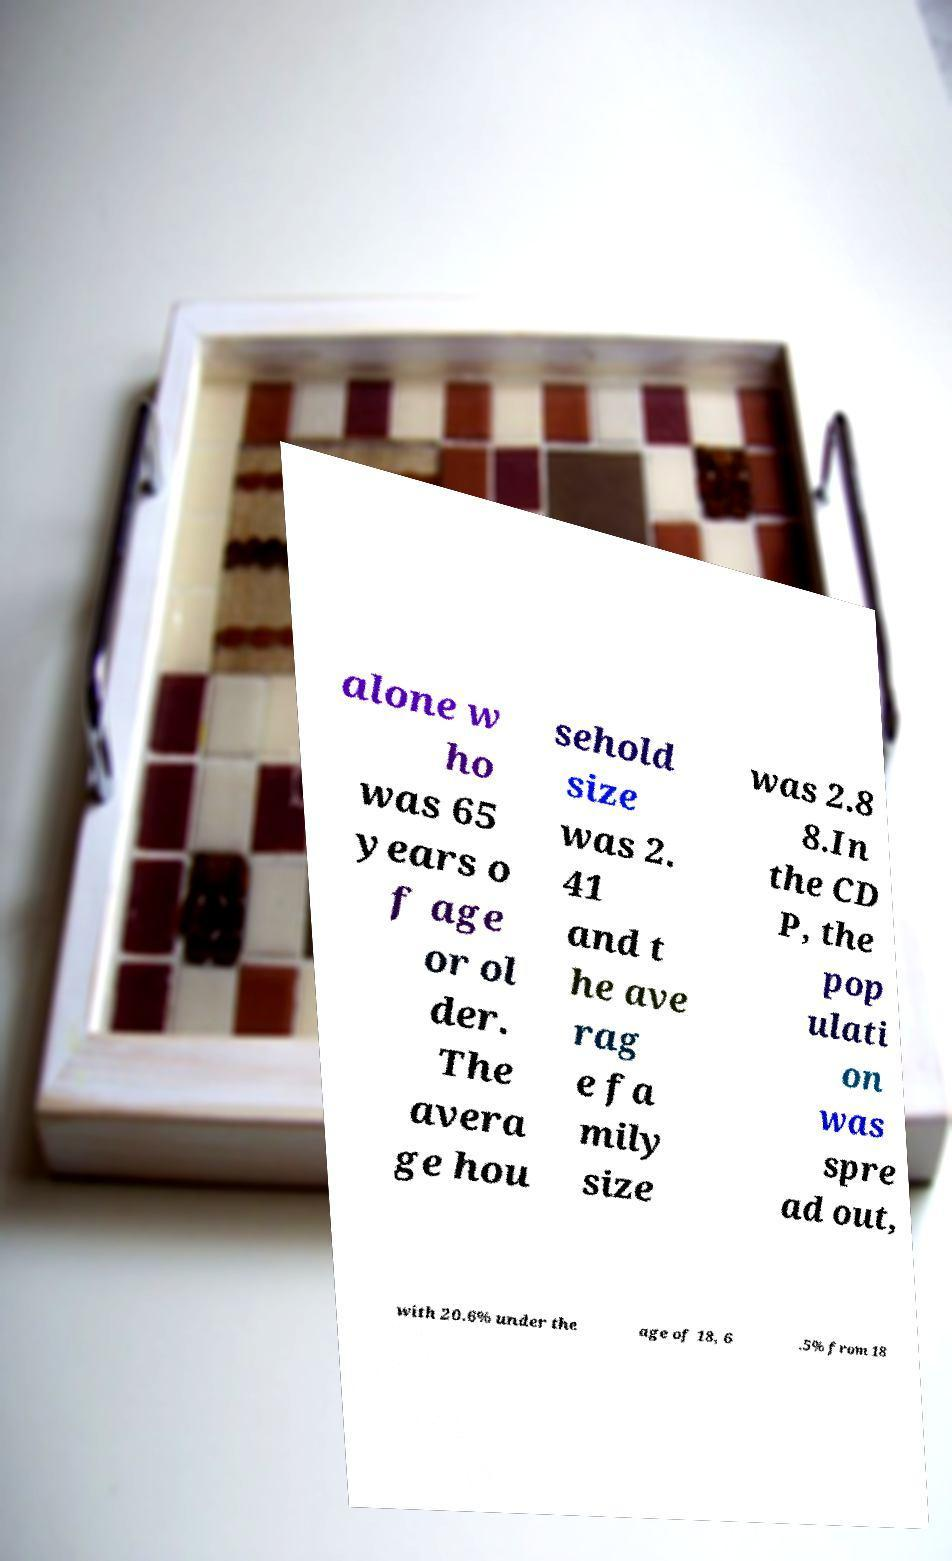I need the written content from this picture converted into text. Can you do that? alone w ho was 65 years o f age or ol der. The avera ge hou sehold size was 2. 41 and t he ave rag e fa mily size was 2.8 8.In the CD P, the pop ulati on was spre ad out, with 20.6% under the age of 18, 6 .5% from 18 